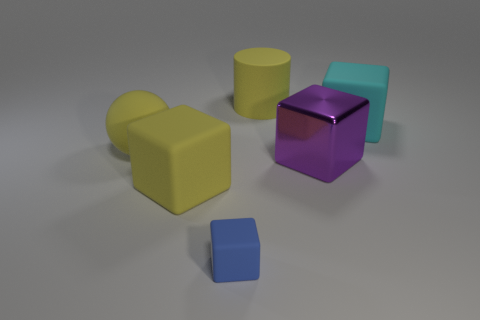Subtract all yellow rubber blocks. How many blocks are left? 3 Subtract 0 green cubes. How many objects are left? 6 Subtract all cylinders. How many objects are left? 5 Subtract 2 cubes. How many cubes are left? 2 Subtract all gray balls. Subtract all cyan cylinders. How many balls are left? 1 Subtract all red blocks. How many blue cylinders are left? 0 Subtract all tiny brown cubes. Subtract all large shiny objects. How many objects are left? 5 Add 3 big yellow matte balls. How many big yellow matte balls are left? 4 Add 2 purple matte blocks. How many purple matte blocks exist? 2 Add 3 yellow matte blocks. How many objects exist? 9 